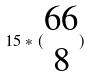<formula> <loc_0><loc_0><loc_500><loc_500>1 5 * ( \begin{matrix} 6 6 \\ 8 \end{matrix} )</formula> 